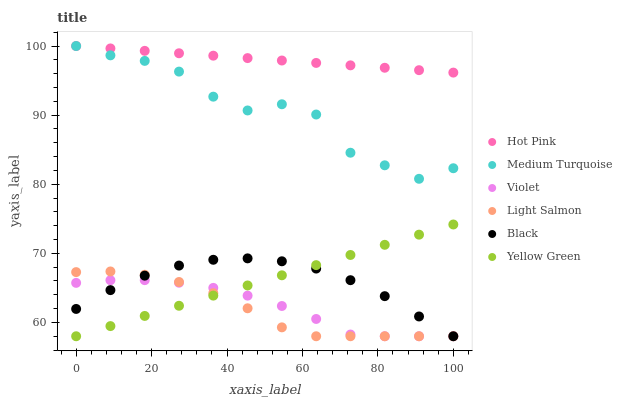Does Light Salmon have the minimum area under the curve?
Answer yes or no. Yes. Does Hot Pink have the maximum area under the curve?
Answer yes or no. Yes. Does Yellow Green have the minimum area under the curve?
Answer yes or no. No. Does Yellow Green have the maximum area under the curve?
Answer yes or no. No. Is Yellow Green the smoothest?
Answer yes or no. Yes. Is Medium Turquoise the roughest?
Answer yes or no. Yes. Is Hot Pink the smoothest?
Answer yes or no. No. Is Hot Pink the roughest?
Answer yes or no. No. Does Light Salmon have the lowest value?
Answer yes or no. Yes. Does Hot Pink have the lowest value?
Answer yes or no. No. Does Medium Turquoise have the highest value?
Answer yes or no. Yes. Does Yellow Green have the highest value?
Answer yes or no. No. Is Black less than Hot Pink?
Answer yes or no. Yes. Is Hot Pink greater than Light Salmon?
Answer yes or no. Yes. Does Violet intersect Yellow Green?
Answer yes or no. Yes. Is Violet less than Yellow Green?
Answer yes or no. No. Is Violet greater than Yellow Green?
Answer yes or no. No. Does Black intersect Hot Pink?
Answer yes or no. No. 